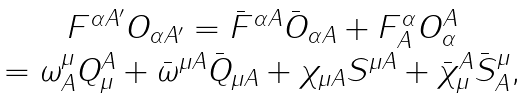<formula> <loc_0><loc_0><loc_500><loc_500>\begin{array} { c } F ^ { \alpha A ^ { \prime } } O _ { \alpha A ^ { \prime } } = \bar { F } ^ { \alpha A } \bar { O } _ { \alpha A } + F ^ { \alpha } _ { A } O ^ { A } _ { \alpha } \\ = \omega ^ { \mu } _ { A } Q ^ { A } _ { \mu } + \bar { \omega } ^ { \mu A } \bar { Q } _ { \mu A } + \chi _ { \mu A } S ^ { \mu A } + \bar { \chi } ^ { A } _ { \mu } \bar { S } ^ { \mu } _ { A } , \end{array}</formula> 